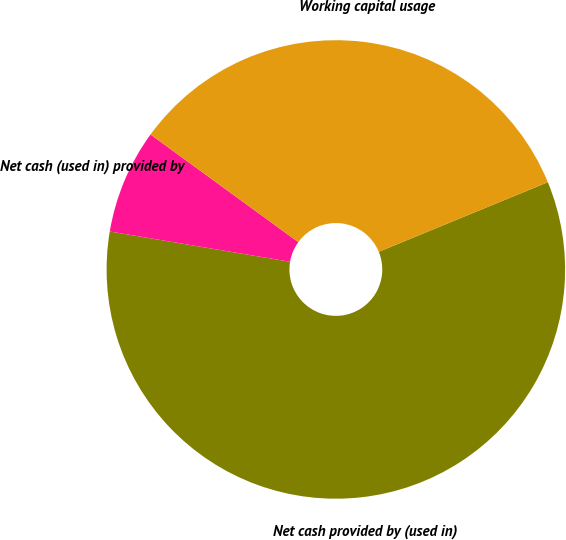<chart> <loc_0><loc_0><loc_500><loc_500><pie_chart><fcel>Net cash provided by (used in)<fcel>Net cash (used in) provided by<fcel>Working capital usage<nl><fcel>58.87%<fcel>7.37%<fcel>33.77%<nl></chart> 